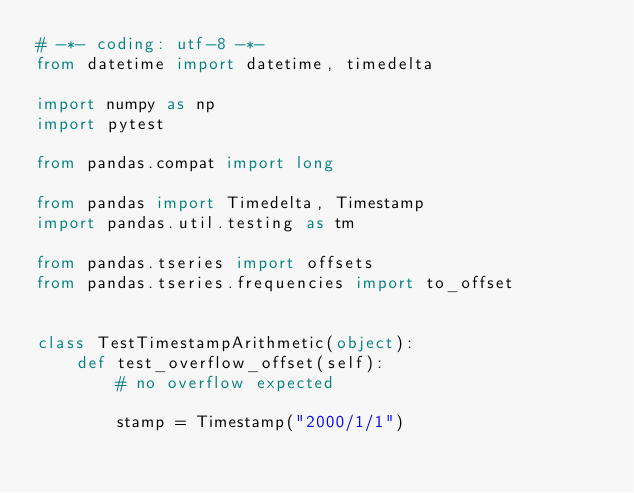<code> <loc_0><loc_0><loc_500><loc_500><_Python_># -*- coding: utf-8 -*-
from datetime import datetime, timedelta

import numpy as np
import pytest

from pandas.compat import long

from pandas import Timedelta, Timestamp
import pandas.util.testing as tm

from pandas.tseries import offsets
from pandas.tseries.frequencies import to_offset


class TestTimestampArithmetic(object):
    def test_overflow_offset(self):
        # no overflow expected

        stamp = Timestamp("2000/1/1")</code> 